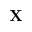Convert formula to latex. <formula><loc_0><loc_0><loc_500><loc_500>X</formula> 